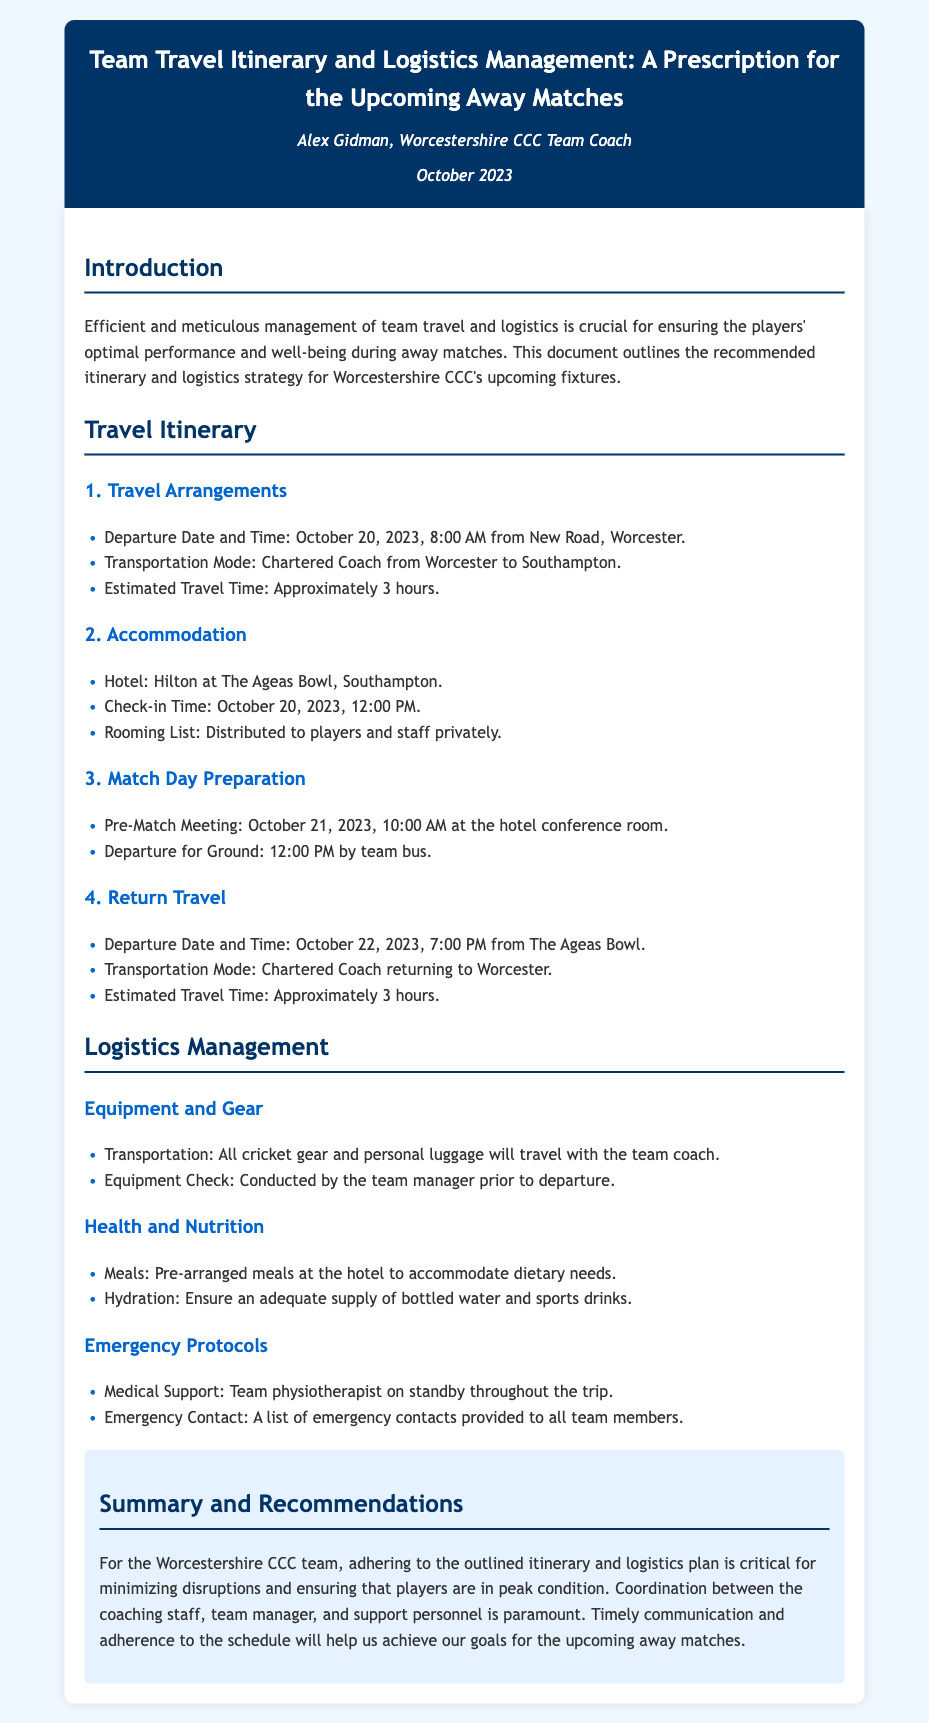What is the departure date and time? The departure date and time is specified in the travel arrangements section.
Answer: October 20, 2023, 8:00 AM What is the mode of transportation to Southampton? The document states the mode of transportation in the travel arrangements section.
Answer: Chartered Coach What is the hotel name for accommodation? The hotel name is mentioned in the accommodation section of the document.
Answer: Hilton at The Ageas Bowl When is the pre-match meeting scheduled? The pre-match meeting time is outlined in the match day preparation section.
Answer: October 21, 2023, 10:00 AM Who is on standby for medical support? The document provides information about medical support personnel in the emergency protocols section.
Answer: Team physiotherapist What will travel with the team coach? The logistics management section specifies what will be transported with the team coach.
Answer: All cricket gear and personal luggage What time will the team depart for home? The document mentions the return travel time in the travel itinerary section.
Answer: 7:00 PM How long is the estimated travel time to Southampton? The estimated travel time is noted in the travel arrangements of the document.
Answer: Approximately 3 hours What is emphasized for the success of the trip? The summary and recommendations section highlights key factors for success in the plan.
Answer: Coordination and timely communication 